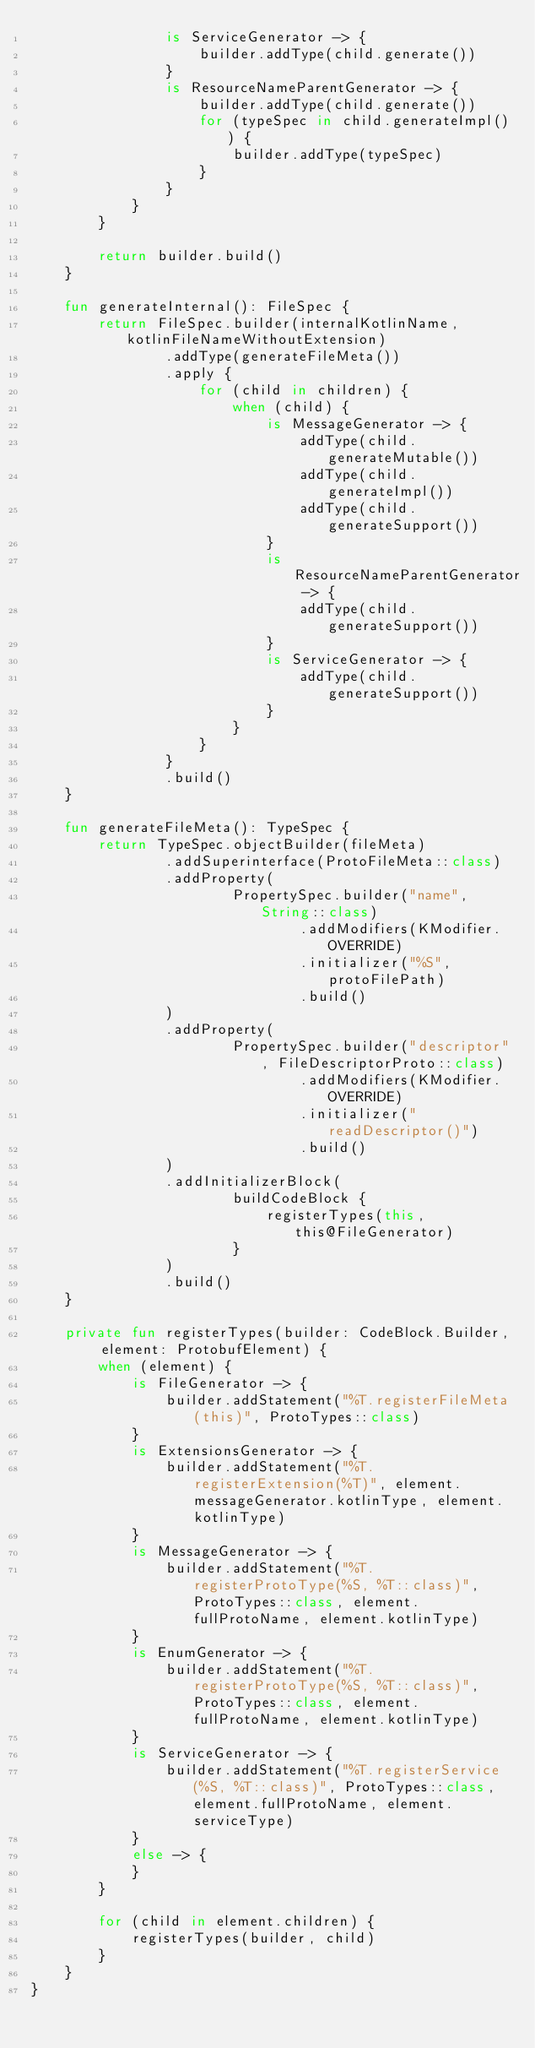Convert code to text. <code><loc_0><loc_0><loc_500><loc_500><_Kotlin_>                is ServiceGenerator -> {
                    builder.addType(child.generate())
                }
                is ResourceNameParentGenerator -> {
                    builder.addType(child.generate())
                    for (typeSpec in child.generateImpl()) {
                        builder.addType(typeSpec)
                    }
                }
            }
        }

        return builder.build()
    }

    fun generateInternal(): FileSpec {
        return FileSpec.builder(internalKotlinName, kotlinFileNameWithoutExtension)
                .addType(generateFileMeta())
                .apply {
                    for (child in children) {
                        when (child) {
                            is MessageGenerator -> {
                                addType(child.generateMutable())
                                addType(child.generateImpl())
                                addType(child.generateSupport())
                            }
                            is ResourceNameParentGenerator -> {
                                addType(child.generateSupport())
                            }
                            is ServiceGenerator -> {
                                addType(child.generateSupport())
                            }
                        }
                    }
                }
                .build()
    }

    fun generateFileMeta(): TypeSpec {
        return TypeSpec.objectBuilder(fileMeta)
                .addSuperinterface(ProtoFileMeta::class)
                .addProperty(
                        PropertySpec.builder("name", String::class)
                                .addModifiers(KModifier.OVERRIDE)
                                .initializer("%S", protoFilePath)
                                .build()
                )
                .addProperty(
                        PropertySpec.builder("descriptor", FileDescriptorProto::class)
                                .addModifiers(KModifier.OVERRIDE)
                                .initializer("readDescriptor()")
                                .build()
                )
                .addInitializerBlock(
                        buildCodeBlock {
                            registerTypes(this, this@FileGenerator)
                        }
                )
                .build()
    }

    private fun registerTypes(builder: CodeBlock.Builder, element: ProtobufElement) {
        when (element) {
            is FileGenerator -> {
                builder.addStatement("%T.registerFileMeta(this)", ProtoTypes::class)
            }
            is ExtensionsGenerator -> {
                builder.addStatement("%T.registerExtension(%T)", element.messageGenerator.kotlinType, element.kotlinType)
            }
            is MessageGenerator -> {
                builder.addStatement("%T.registerProtoType(%S, %T::class)", ProtoTypes::class, element.fullProtoName, element.kotlinType)
            }
            is EnumGenerator -> {
                builder.addStatement("%T.registerProtoType(%S, %T::class)", ProtoTypes::class, element.fullProtoName, element.kotlinType)
            }
            is ServiceGenerator -> {
                builder.addStatement("%T.registerService(%S, %T::class)", ProtoTypes::class, element.fullProtoName, element.serviceType)
            }
            else -> {
            }
        }

        for (child in element.children) {
            registerTypes(builder, child)
        }
    }
}
</code> 